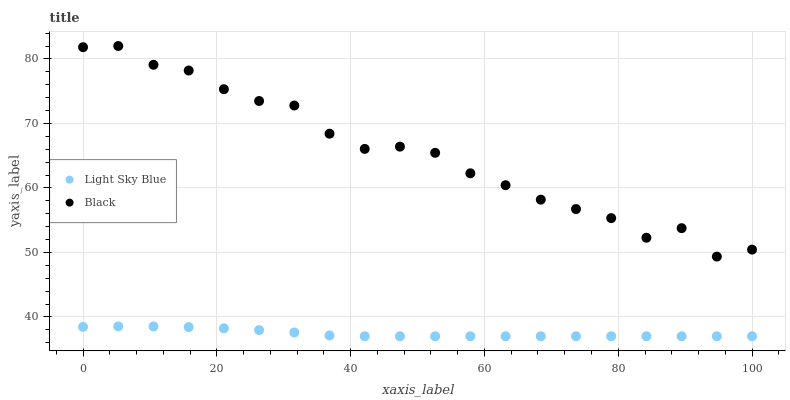Does Light Sky Blue have the minimum area under the curve?
Answer yes or no. Yes. Does Black have the maximum area under the curve?
Answer yes or no. Yes. Does Black have the minimum area under the curve?
Answer yes or no. No. Is Light Sky Blue the smoothest?
Answer yes or no. Yes. Is Black the roughest?
Answer yes or no. Yes. Is Black the smoothest?
Answer yes or no. No. Does Light Sky Blue have the lowest value?
Answer yes or no. Yes. Does Black have the lowest value?
Answer yes or no. No. Does Black have the highest value?
Answer yes or no. Yes. Is Light Sky Blue less than Black?
Answer yes or no. Yes. Is Black greater than Light Sky Blue?
Answer yes or no. Yes. Does Light Sky Blue intersect Black?
Answer yes or no. No. 